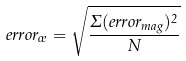<formula> <loc_0><loc_0><loc_500><loc_500>e r r o r _ { \sigma } = \sqrt { \frac { \Sigma ( e r r o r _ { m a g } ) ^ { 2 } } { N } }</formula> 